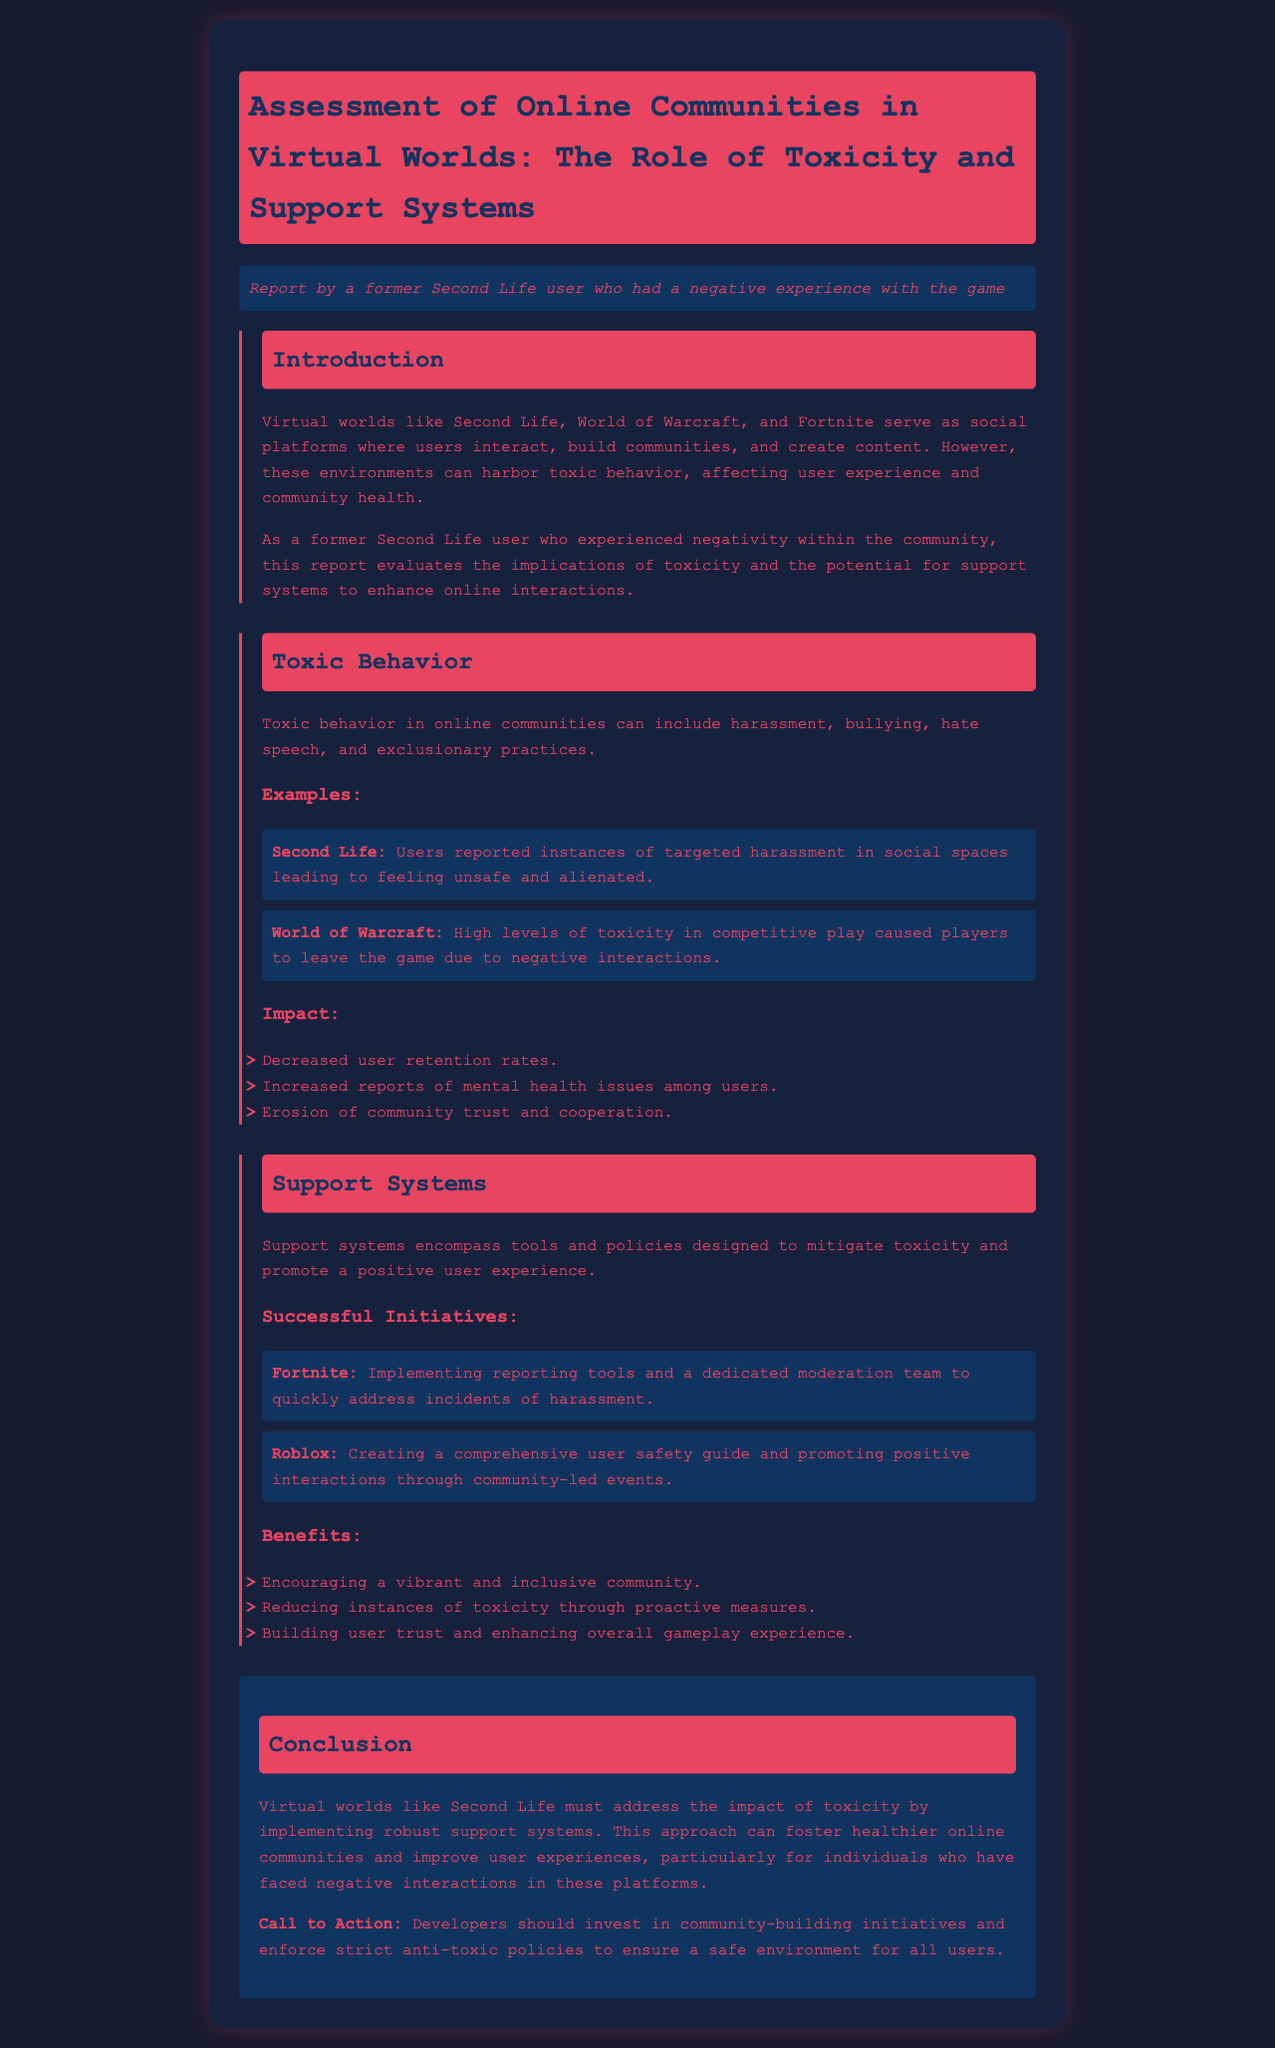what is the title of the report? The title of the report is clearly stated at the beginning of the document.
Answer: Assessment of Online Communities in Virtual Worlds: The Role of Toxicity and Support Systems what game had users report targeted harassment? The document provides specific examples of games where toxic behavior has been reported.
Answer: Second Life what are two examples of toxic behavior mentioned? The document lists several forms of toxic behavior occurring in online communities.
Answer: harassment, bullying how many successful initiatives are mentioned in the support systems section? The document lists initiatives indicating the efforts undertaken within various games.
Answer: 2 what benefit is associated with reducing instances of toxicity? The document explains the benefits of implementing support systems in online communities.
Answer: Reducing instances of toxicity through proactive measures what is the call to action from the conclusion? The conclusion provides a specific recommendation to game developers regarding community management.
Answer: Developers should invest in community-building initiatives what is one impact of toxic behavior mentioned in the document? The document outlines specific negative consequences of toxic behavior on community health.
Answer: Increased reports of mental health issues among users what does the report evaluate based on the author's experience? The perspective of the author provides insight into the overall thematic assessment of online interactions.
Answer: toxicity and the potential for support systems 